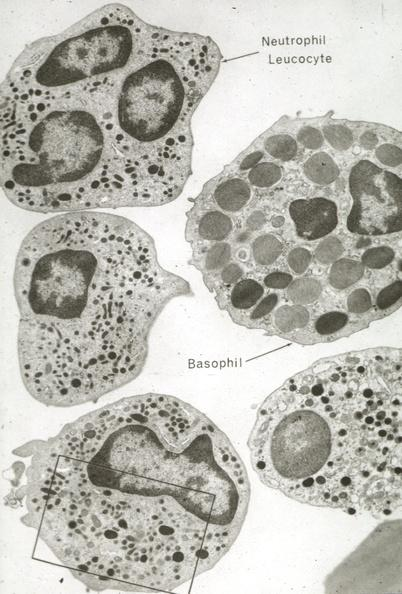what is present?
Answer the question using a single word or phrase. Blood 